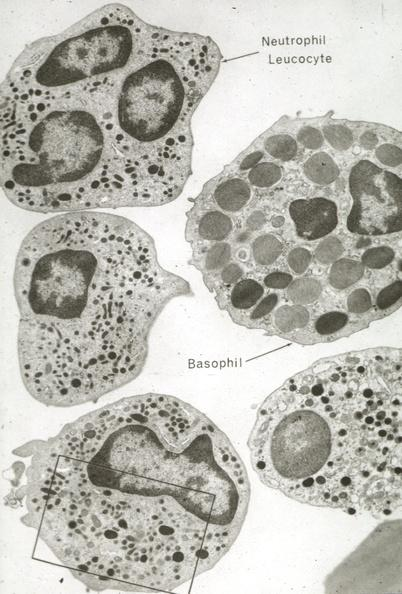what is present?
Answer the question using a single word or phrase. Blood 